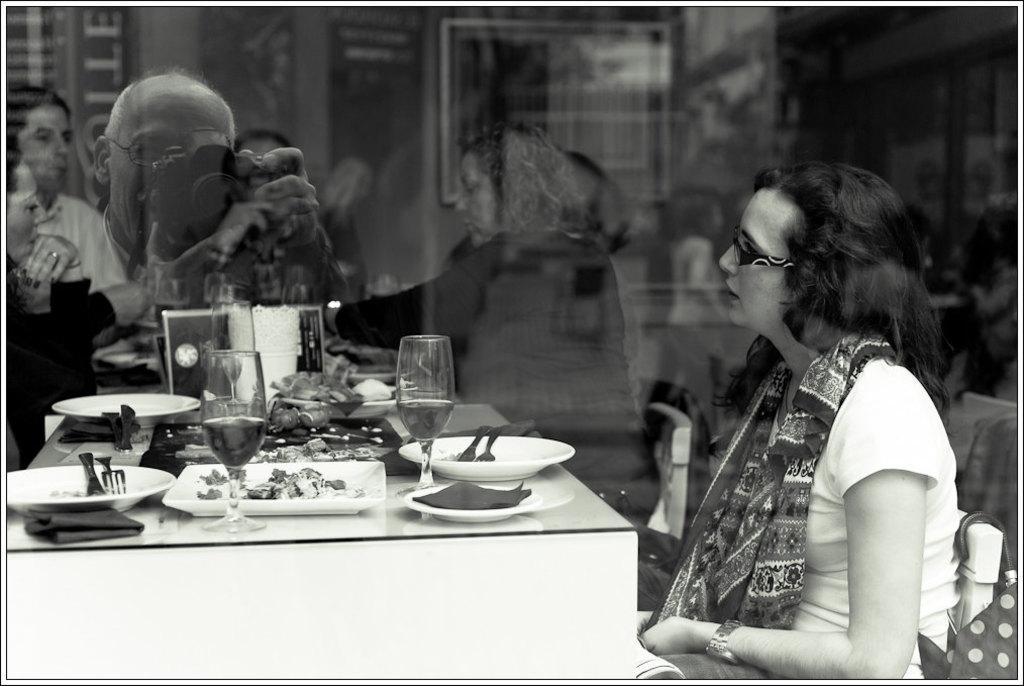Can you describe this image briefly? In this picture we can see woman sitting on chair wore scarf, goggle and in front of her we can see table and on table we have plates, fork, knife, glass with drink in it, kerchief, some food and from glass some persons sitting and here person taking picture with camera. 